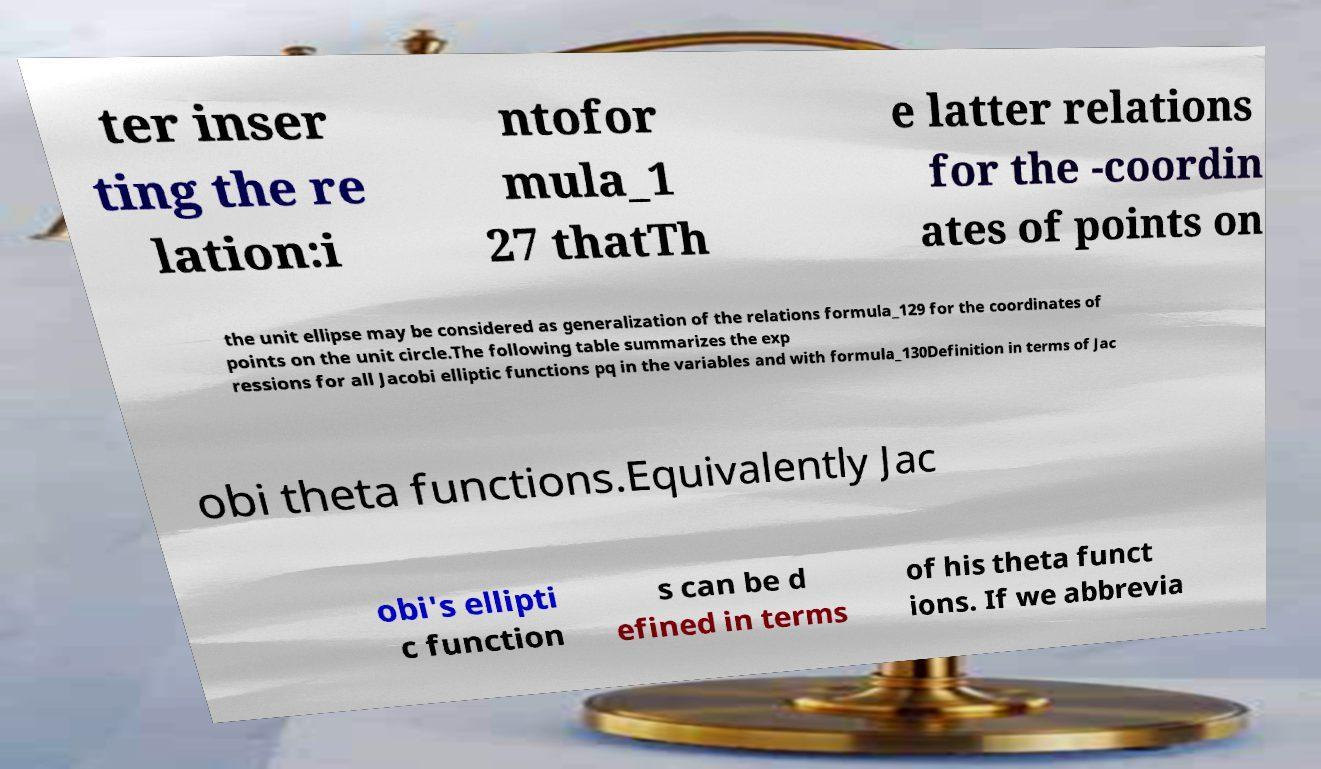Can you accurately transcribe the text from the provided image for me? ter inser ting the re lation:i ntofor mula_1 27 thatTh e latter relations for the -coordin ates of points on the unit ellipse may be considered as generalization of the relations formula_129 for the coordinates of points on the unit circle.The following table summarizes the exp ressions for all Jacobi elliptic functions pq in the variables and with formula_130Definition in terms of Jac obi theta functions.Equivalently Jac obi's ellipti c function s can be d efined in terms of his theta funct ions. If we abbrevia 